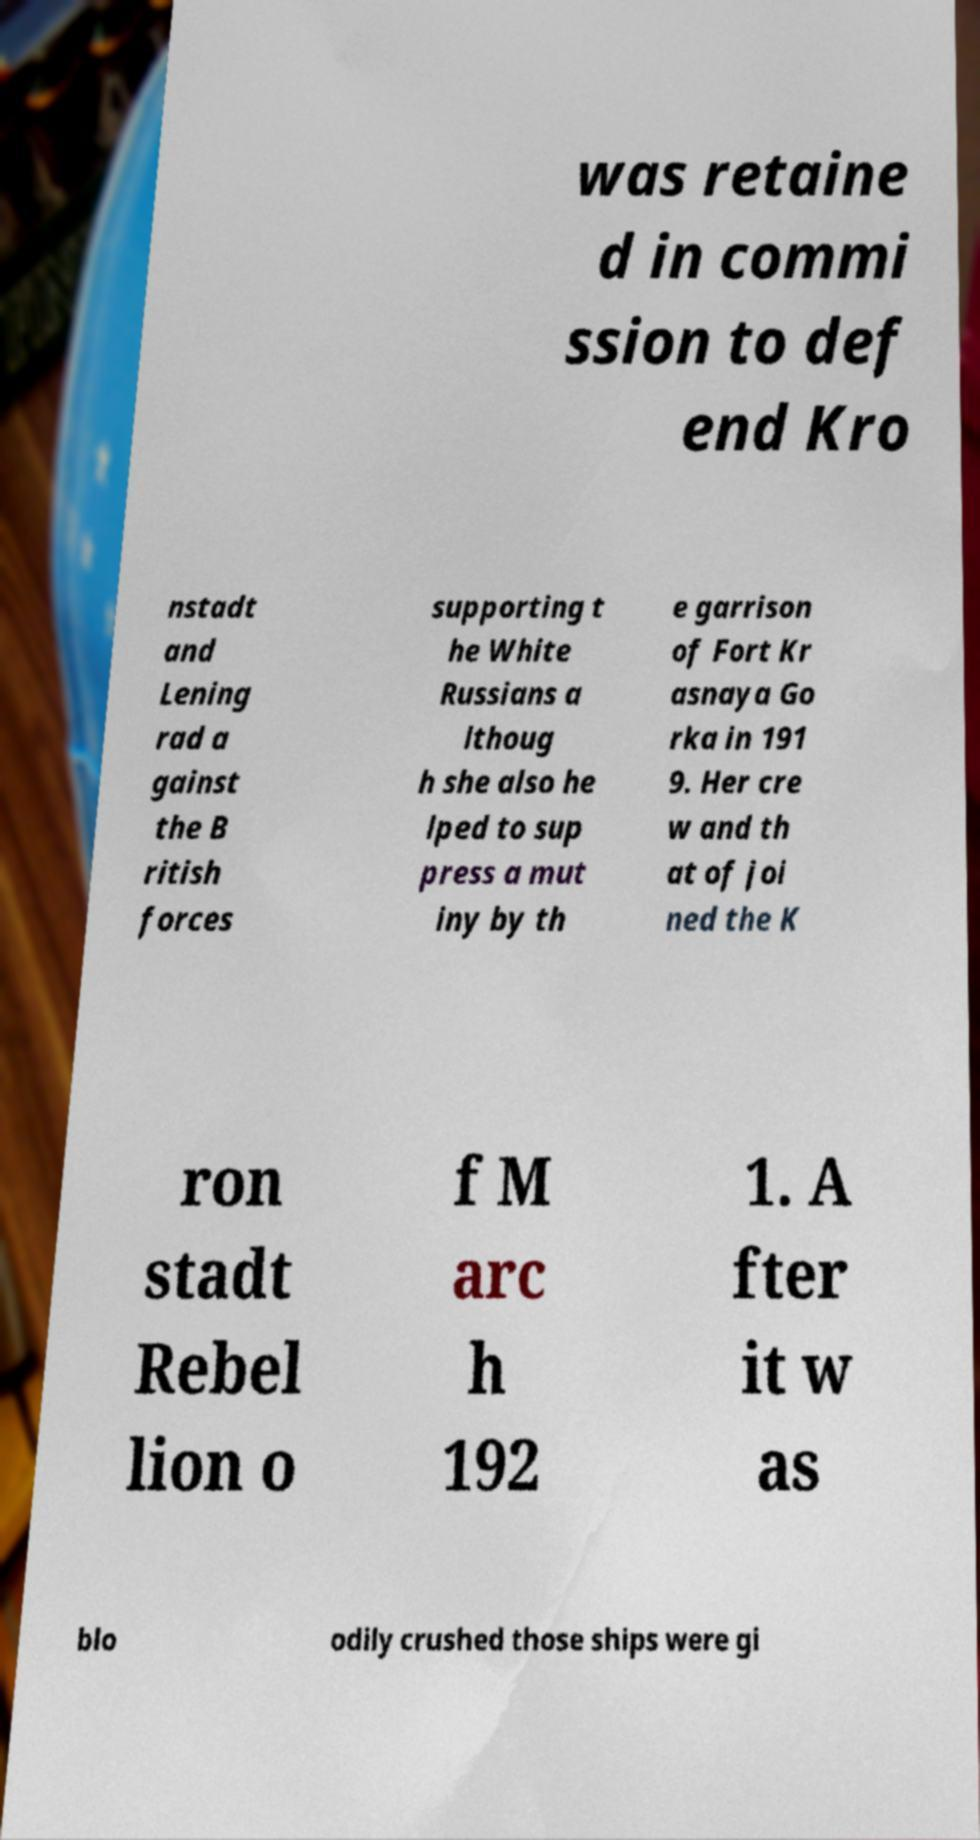There's text embedded in this image that I need extracted. Can you transcribe it verbatim? was retaine d in commi ssion to def end Kro nstadt and Lening rad a gainst the B ritish forces supporting t he White Russians a lthoug h she also he lped to sup press a mut iny by th e garrison of Fort Kr asnaya Go rka in 191 9. Her cre w and th at of joi ned the K ron stadt Rebel lion o f M arc h 192 1. A fter it w as blo odily crushed those ships were gi 